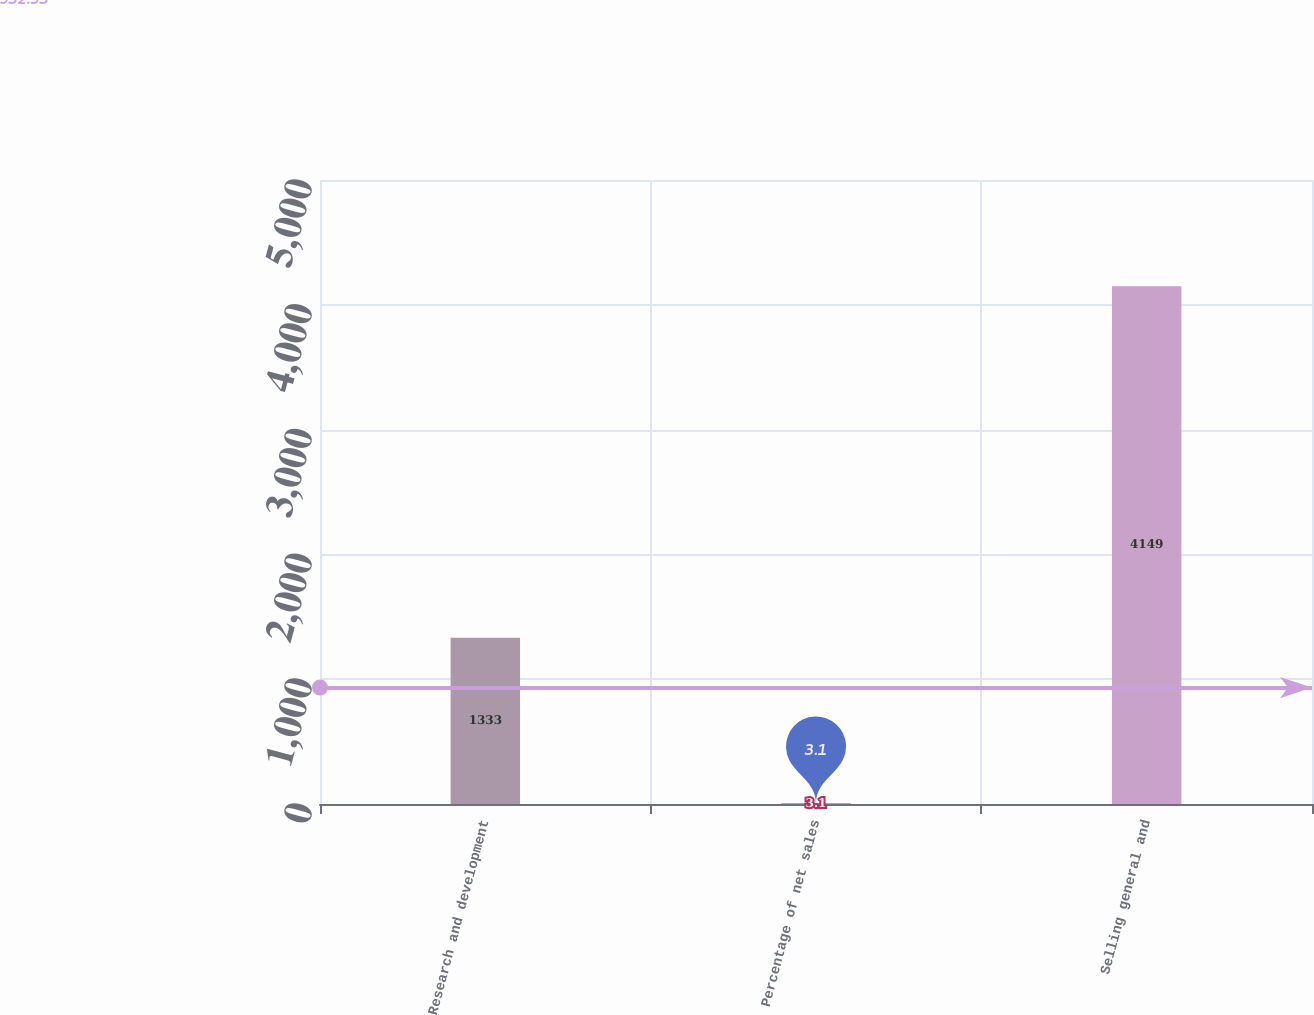Convert chart to OTSL. <chart><loc_0><loc_0><loc_500><loc_500><bar_chart><fcel>Research and development<fcel>Percentage of net sales<fcel>Selling general and<nl><fcel>1333<fcel>3.1<fcel>4149<nl></chart> 